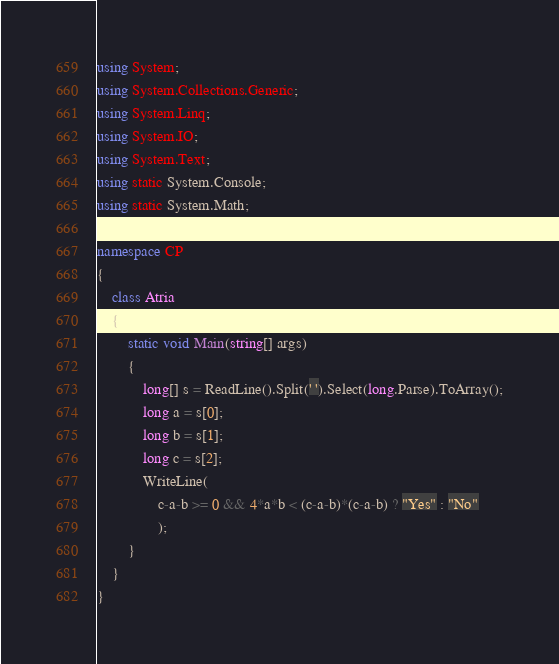Convert code to text. <code><loc_0><loc_0><loc_500><loc_500><_C#_>using System;
using System.Collections.Generic;
using System.Linq;
using System.IO;
using System.Text;
using static System.Console;
using static System.Math;

namespace CP
{
    class Atria
    {
        static void Main(string[] args)
        {
            long[] s = ReadLine().Split(' ').Select(long.Parse).ToArray();
            long a = s[0];
            long b = s[1];
            long c = s[2];
            WriteLine(
                c-a-b >= 0 && 4*a*b < (c-a-b)*(c-a-b) ? "Yes" : "No"
                );
        }
    }
}
</code> 